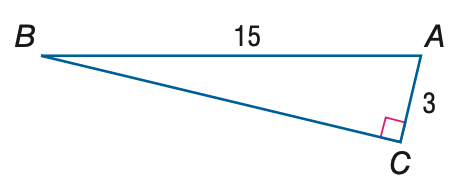Answer the mathemtical geometry problem and directly provide the correct option letter.
Question: Find the measure of \angle A to the nearest tenth.
Choices: A: 11.3 B: 11.5 C: 78.5 D: 78.7 C 